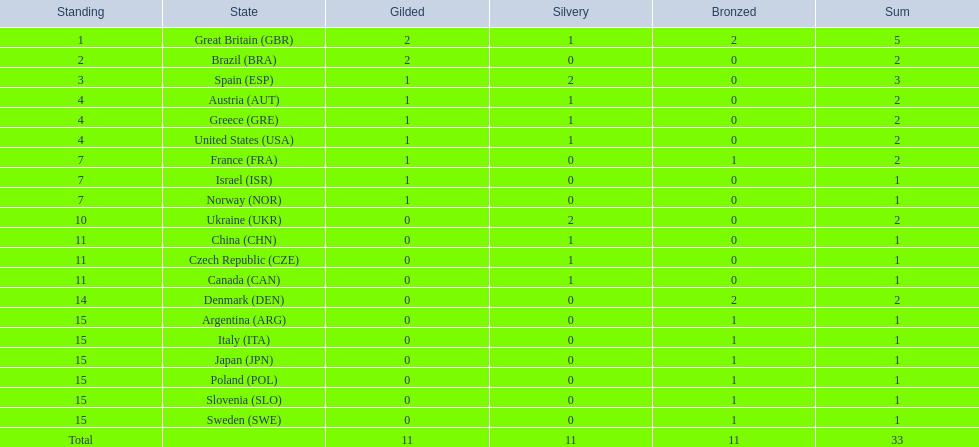How many medals did each country receive? 5, 2, 3, 2, 2, 2, 2, 1, 1, 2, 1, 1, 1, 2, 1, 1, 1, 1, 1, 1. Which country received 3 medals? Spain (ESP). 